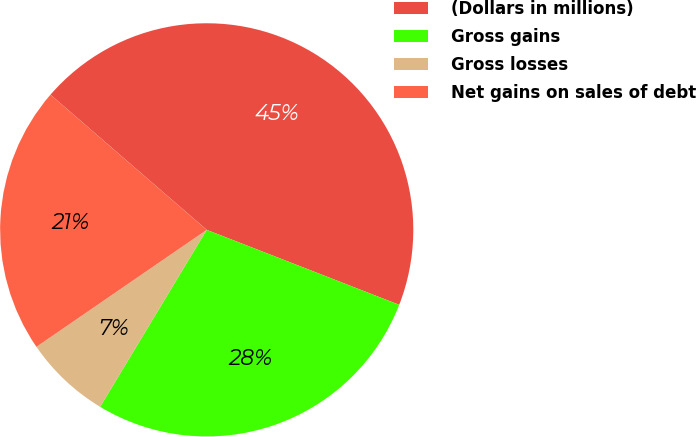<chart> <loc_0><loc_0><loc_500><loc_500><pie_chart><fcel>(Dollars in millions)<fcel>Gross gains<fcel>Gross losses<fcel>Net gains on sales of debt<nl><fcel>44.56%<fcel>27.72%<fcel>6.79%<fcel>20.93%<nl></chart> 